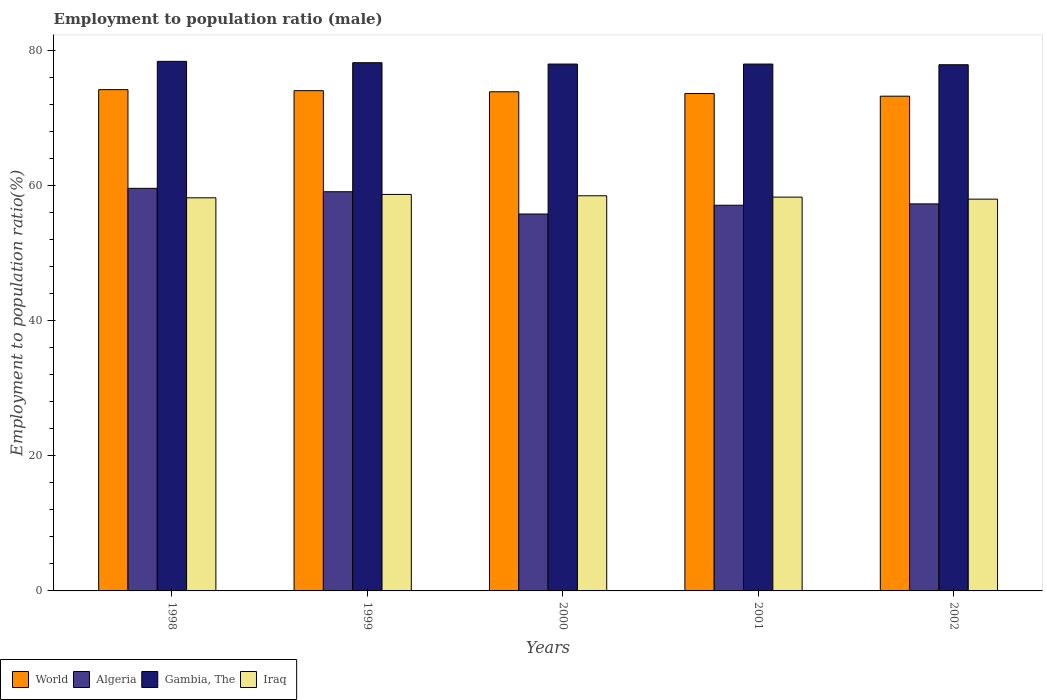How many different coloured bars are there?
Ensure brevity in your answer.  4. How many groups of bars are there?
Your answer should be compact. 5. Are the number of bars per tick equal to the number of legend labels?
Offer a terse response. Yes. Are the number of bars on each tick of the X-axis equal?
Your answer should be compact. Yes. How many bars are there on the 2nd tick from the right?
Make the answer very short. 4. What is the employment to population ratio in World in 2002?
Provide a succinct answer. 73.25. Across all years, what is the maximum employment to population ratio in World?
Provide a succinct answer. 74.21. Across all years, what is the minimum employment to population ratio in Gambia, The?
Offer a terse response. 77.9. In which year was the employment to population ratio in World maximum?
Make the answer very short. 1998. What is the total employment to population ratio in Gambia, The in the graph?
Your answer should be compact. 390.5. What is the difference between the employment to population ratio in Algeria in 1998 and that in 2002?
Your response must be concise. 2.3. What is the difference between the employment to population ratio in World in 2000 and the employment to population ratio in Gambia, The in 2001?
Keep it short and to the point. -4.11. What is the average employment to population ratio in Gambia, The per year?
Provide a succinct answer. 78.1. In the year 1998, what is the difference between the employment to population ratio in World and employment to population ratio in Algeria?
Make the answer very short. 14.61. In how many years, is the employment to population ratio in Gambia, The greater than 24 %?
Offer a terse response. 5. What is the ratio of the employment to population ratio in Algeria in 1999 to that in 2000?
Ensure brevity in your answer.  1.06. What is the difference between the highest and the second highest employment to population ratio in Iraq?
Offer a terse response. 0.2. What is the difference between the highest and the lowest employment to population ratio in Iraq?
Your response must be concise. 0.7. What does the 2nd bar from the left in 1999 represents?
Provide a short and direct response. Algeria. What does the 4th bar from the right in 2001 represents?
Your answer should be compact. World. Is it the case that in every year, the sum of the employment to population ratio in Gambia, The and employment to population ratio in Iraq is greater than the employment to population ratio in World?
Ensure brevity in your answer.  Yes. Are all the bars in the graph horizontal?
Offer a very short reply. No. What is the difference between two consecutive major ticks on the Y-axis?
Offer a very short reply. 20. Are the values on the major ticks of Y-axis written in scientific E-notation?
Your answer should be compact. No. Does the graph contain any zero values?
Your answer should be very brief. No. Does the graph contain grids?
Keep it short and to the point. No. Where does the legend appear in the graph?
Your answer should be compact. Bottom left. How many legend labels are there?
Your answer should be compact. 4. How are the legend labels stacked?
Provide a short and direct response. Horizontal. What is the title of the graph?
Keep it short and to the point. Employment to population ratio (male). Does "Moldova" appear as one of the legend labels in the graph?
Make the answer very short. No. What is the label or title of the X-axis?
Your response must be concise. Years. What is the label or title of the Y-axis?
Your answer should be compact. Employment to population ratio(%). What is the Employment to population ratio(%) of World in 1998?
Provide a short and direct response. 74.21. What is the Employment to population ratio(%) in Algeria in 1998?
Your answer should be compact. 59.6. What is the Employment to population ratio(%) of Gambia, The in 1998?
Provide a succinct answer. 78.4. What is the Employment to population ratio(%) in Iraq in 1998?
Your response must be concise. 58.2. What is the Employment to population ratio(%) of World in 1999?
Keep it short and to the point. 74.06. What is the Employment to population ratio(%) of Algeria in 1999?
Provide a succinct answer. 59.1. What is the Employment to population ratio(%) of Gambia, The in 1999?
Provide a succinct answer. 78.2. What is the Employment to population ratio(%) of Iraq in 1999?
Ensure brevity in your answer.  58.7. What is the Employment to population ratio(%) of World in 2000?
Your answer should be very brief. 73.89. What is the Employment to population ratio(%) in Algeria in 2000?
Offer a very short reply. 55.8. What is the Employment to population ratio(%) of Gambia, The in 2000?
Provide a short and direct response. 78. What is the Employment to population ratio(%) of Iraq in 2000?
Your response must be concise. 58.5. What is the Employment to population ratio(%) of World in 2001?
Keep it short and to the point. 73.64. What is the Employment to population ratio(%) of Algeria in 2001?
Offer a very short reply. 57.1. What is the Employment to population ratio(%) of Gambia, The in 2001?
Provide a succinct answer. 78. What is the Employment to population ratio(%) of Iraq in 2001?
Provide a succinct answer. 58.3. What is the Employment to population ratio(%) in World in 2002?
Your answer should be very brief. 73.25. What is the Employment to population ratio(%) of Algeria in 2002?
Your response must be concise. 57.3. What is the Employment to population ratio(%) in Gambia, The in 2002?
Offer a terse response. 77.9. What is the Employment to population ratio(%) in Iraq in 2002?
Give a very brief answer. 58. Across all years, what is the maximum Employment to population ratio(%) of World?
Your answer should be compact. 74.21. Across all years, what is the maximum Employment to population ratio(%) in Algeria?
Your answer should be very brief. 59.6. Across all years, what is the maximum Employment to population ratio(%) in Gambia, The?
Make the answer very short. 78.4. Across all years, what is the maximum Employment to population ratio(%) of Iraq?
Offer a very short reply. 58.7. Across all years, what is the minimum Employment to population ratio(%) in World?
Your answer should be compact. 73.25. Across all years, what is the minimum Employment to population ratio(%) in Algeria?
Make the answer very short. 55.8. Across all years, what is the minimum Employment to population ratio(%) in Gambia, The?
Ensure brevity in your answer.  77.9. What is the total Employment to population ratio(%) of World in the graph?
Give a very brief answer. 369.05. What is the total Employment to population ratio(%) of Algeria in the graph?
Ensure brevity in your answer.  288.9. What is the total Employment to population ratio(%) of Gambia, The in the graph?
Make the answer very short. 390.5. What is the total Employment to population ratio(%) of Iraq in the graph?
Give a very brief answer. 291.7. What is the difference between the Employment to population ratio(%) of World in 1998 and that in 1999?
Offer a very short reply. 0.15. What is the difference between the Employment to population ratio(%) in Gambia, The in 1998 and that in 1999?
Give a very brief answer. 0.2. What is the difference between the Employment to population ratio(%) of Iraq in 1998 and that in 1999?
Your answer should be very brief. -0.5. What is the difference between the Employment to population ratio(%) of World in 1998 and that in 2000?
Offer a very short reply. 0.32. What is the difference between the Employment to population ratio(%) of Algeria in 1998 and that in 2000?
Keep it short and to the point. 3.8. What is the difference between the Employment to population ratio(%) in Iraq in 1998 and that in 2000?
Give a very brief answer. -0.3. What is the difference between the Employment to population ratio(%) of World in 1998 and that in 2001?
Offer a terse response. 0.57. What is the difference between the Employment to population ratio(%) in Gambia, The in 1998 and that in 2001?
Your response must be concise. 0.4. What is the difference between the Employment to population ratio(%) of Iraq in 1998 and that in 2001?
Provide a short and direct response. -0.1. What is the difference between the Employment to population ratio(%) of World in 1998 and that in 2002?
Offer a terse response. 0.97. What is the difference between the Employment to population ratio(%) of Algeria in 1998 and that in 2002?
Offer a very short reply. 2.3. What is the difference between the Employment to population ratio(%) of Gambia, The in 1998 and that in 2002?
Your answer should be very brief. 0.5. What is the difference between the Employment to population ratio(%) of Algeria in 1999 and that in 2000?
Your response must be concise. 3.3. What is the difference between the Employment to population ratio(%) in World in 1999 and that in 2001?
Ensure brevity in your answer.  0.42. What is the difference between the Employment to population ratio(%) in Algeria in 1999 and that in 2001?
Give a very brief answer. 2. What is the difference between the Employment to population ratio(%) of Iraq in 1999 and that in 2001?
Your response must be concise. 0.4. What is the difference between the Employment to population ratio(%) in World in 1999 and that in 2002?
Your response must be concise. 0.81. What is the difference between the Employment to population ratio(%) of Algeria in 1999 and that in 2002?
Ensure brevity in your answer.  1.8. What is the difference between the Employment to population ratio(%) in Iraq in 1999 and that in 2002?
Give a very brief answer. 0.7. What is the difference between the Employment to population ratio(%) in World in 2000 and that in 2001?
Offer a terse response. 0.26. What is the difference between the Employment to population ratio(%) in Algeria in 2000 and that in 2001?
Provide a succinct answer. -1.3. What is the difference between the Employment to population ratio(%) in Gambia, The in 2000 and that in 2001?
Ensure brevity in your answer.  0. What is the difference between the Employment to population ratio(%) of World in 2000 and that in 2002?
Your answer should be compact. 0.65. What is the difference between the Employment to population ratio(%) of Iraq in 2000 and that in 2002?
Offer a terse response. 0.5. What is the difference between the Employment to population ratio(%) of World in 2001 and that in 2002?
Offer a terse response. 0.39. What is the difference between the Employment to population ratio(%) of Algeria in 2001 and that in 2002?
Make the answer very short. -0.2. What is the difference between the Employment to population ratio(%) of Gambia, The in 2001 and that in 2002?
Your response must be concise. 0.1. What is the difference between the Employment to population ratio(%) in World in 1998 and the Employment to population ratio(%) in Algeria in 1999?
Your answer should be compact. 15.11. What is the difference between the Employment to population ratio(%) in World in 1998 and the Employment to population ratio(%) in Gambia, The in 1999?
Ensure brevity in your answer.  -3.99. What is the difference between the Employment to population ratio(%) of World in 1998 and the Employment to population ratio(%) of Iraq in 1999?
Provide a succinct answer. 15.51. What is the difference between the Employment to population ratio(%) of Algeria in 1998 and the Employment to population ratio(%) of Gambia, The in 1999?
Your answer should be compact. -18.6. What is the difference between the Employment to population ratio(%) in World in 1998 and the Employment to population ratio(%) in Algeria in 2000?
Offer a very short reply. 18.41. What is the difference between the Employment to population ratio(%) of World in 1998 and the Employment to population ratio(%) of Gambia, The in 2000?
Give a very brief answer. -3.79. What is the difference between the Employment to population ratio(%) of World in 1998 and the Employment to population ratio(%) of Iraq in 2000?
Make the answer very short. 15.71. What is the difference between the Employment to population ratio(%) of Algeria in 1998 and the Employment to population ratio(%) of Gambia, The in 2000?
Offer a terse response. -18.4. What is the difference between the Employment to population ratio(%) of Algeria in 1998 and the Employment to population ratio(%) of Iraq in 2000?
Offer a very short reply. 1.1. What is the difference between the Employment to population ratio(%) of World in 1998 and the Employment to population ratio(%) of Algeria in 2001?
Your answer should be compact. 17.11. What is the difference between the Employment to population ratio(%) in World in 1998 and the Employment to population ratio(%) in Gambia, The in 2001?
Give a very brief answer. -3.79. What is the difference between the Employment to population ratio(%) in World in 1998 and the Employment to population ratio(%) in Iraq in 2001?
Your response must be concise. 15.91. What is the difference between the Employment to population ratio(%) in Algeria in 1998 and the Employment to population ratio(%) in Gambia, The in 2001?
Ensure brevity in your answer.  -18.4. What is the difference between the Employment to population ratio(%) in Gambia, The in 1998 and the Employment to population ratio(%) in Iraq in 2001?
Your response must be concise. 20.1. What is the difference between the Employment to population ratio(%) in World in 1998 and the Employment to population ratio(%) in Algeria in 2002?
Keep it short and to the point. 16.91. What is the difference between the Employment to population ratio(%) in World in 1998 and the Employment to population ratio(%) in Gambia, The in 2002?
Offer a very short reply. -3.69. What is the difference between the Employment to population ratio(%) in World in 1998 and the Employment to population ratio(%) in Iraq in 2002?
Ensure brevity in your answer.  16.21. What is the difference between the Employment to population ratio(%) of Algeria in 1998 and the Employment to population ratio(%) of Gambia, The in 2002?
Make the answer very short. -18.3. What is the difference between the Employment to population ratio(%) in Algeria in 1998 and the Employment to population ratio(%) in Iraq in 2002?
Make the answer very short. 1.6. What is the difference between the Employment to population ratio(%) in Gambia, The in 1998 and the Employment to population ratio(%) in Iraq in 2002?
Make the answer very short. 20.4. What is the difference between the Employment to population ratio(%) of World in 1999 and the Employment to population ratio(%) of Algeria in 2000?
Provide a short and direct response. 18.26. What is the difference between the Employment to population ratio(%) of World in 1999 and the Employment to population ratio(%) of Gambia, The in 2000?
Offer a terse response. -3.94. What is the difference between the Employment to population ratio(%) in World in 1999 and the Employment to population ratio(%) in Iraq in 2000?
Your answer should be very brief. 15.56. What is the difference between the Employment to population ratio(%) of Algeria in 1999 and the Employment to population ratio(%) of Gambia, The in 2000?
Provide a succinct answer. -18.9. What is the difference between the Employment to population ratio(%) in World in 1999 and the Employment to population ratio(%) in Algeria in 2001?
Provide a short and direct response. 16.96. What is the difference between the Employment to population ratio(%) in World in 1999 and the Employment to population ratio(%) in Gambia, The in 2001?
Offer a very short reply. -3.94. What is the difference between the Employment to population ratio(%) of World in 1999 and the Employment to population ratio(%) of Iraq in 2001?
Provide a short and direct response. 15.76. What is the difference between the Employment to population ratio(%) of Algeria in 1999 and the Employment to population ratio(%) of Gambia, The in 2001?
Your answer should be very brief. -18.9. What is the difference between the Employment to population ratio(%) in Algeria in 1999 and the Employment to population ratio(%) in Iraq in 2001?
Keep it short and to the point. 0.8. What is the difference between the Employment to population ratio(%) of World in 1999 and the Employment to population ratio(%) of Algeria in 2002?
Give a very brief answer. 16.76. What is the difference between the Employment to population ratio(%) in World in 1999 and the Employment to population ratio(%) in Gambia, The in 2002?
Make the answer very short. -3.84. What is the difference between the Employment to population ratio(%) of World in 1999 and the Employment to population ratio(%) of Iraq in 2002?
Your answer should be very brief. 16.06. What is the difference between the Employment to population ratio(%) in Algeria in 1999 and the Employment to population ratio(%) in Gambia, The in 2002?
Provide a short and direct response. -18.8. What is the difference between the Employment to population ratio(%) of Algeria in 1999 and the Employment to population ratio(%) of Iraq in 2002?
Ensure brevity in your answer.  1.1. What is the difference between the Employment to population ratio(%) in Gambia, The in 1999 and the Employment to population ratio(%) in Iraq in 2002?
Provide a succinct answer. 20.2. What is the difference between the Employment to population ratio(%) in World in 2000 and the Employment to population ratio(%) in Algeria in 2001?
Make the answer very short. 16.79. What is the difference between the Employment to population ratio(%) in World in 2000 and the Employment to population ratio(%) in Gambia, The in 2001?
Give a very brief answer. -4.11. What is the difference between the Employment to population ratio(%) of World in 2000 and the Employment to population ratio(%) of Iraq in 2001?
Provide a short and direct response. 15.59. What is the difference between the Employment to population ratio(%) in Algeria in 2000 and the Employment to population ratio(%) in Gambia, The in 2001?
Provide a short and direct response. -22.2. What is the difference between the Employment to population ratio(%) of Gambia, The in 2000 and the Employment to population ratio(%) of Iraq in 2001?
Ensure brevity in your answer.  19.7. What is the difference between the Employment to population ratio(%) in World in 2000 and the Employment to population ratio(%) in Algeria in 2002?
Your response must be concise. 16.59. What is the difference between the Employment to population ratio(%) of World in 2000 and the Employment to population ratio(%) of Gambia, The in 2002?
Ensure brevity in your answer.  -4.01. What is the difference between the Employment to population ratio(%) of World in 2000 and the Employment to population ratio(%) of Iraq in 2002?
Your answer should be very brief. 15.89. What is the difference between the Employment to population ratio(%) of Algeria in 2000 and the Employment to population ratio(%) of Gambia, The in 2002?
Your answer should be very brief. -22.1. What is the difference between the Employment to population ratio(%) in World in 2001 and the Employment to population ratio(%) in Algeria in 2002?
Your response must be concise. 16.34. What is the difference between the Employment to population ratio(%) of World in 2001 and the Employment to population ratio(%) of Gambia, The in 2002?
Ensure brevity in your answer.  -4.26. What is the difference between the Employment to population ratio(%) in World in 2001 and the Employment to population ratio(%) in Iraq in 2002?
Provide a short and direct response. 15.64. What is the difference between the Employment to population ratio(%) in Algeria in 2001 and the Employment to population ratio(%) in Gambia, The in 2002?
Provide a short and direct response. -20.8. What is the difference between the Employment to population ratio(%) in Gambia, The in 2001 and the Employment to population ratio(%) in Iraq in 2002?
Ensure brevity in your answer.  20. What is the average Employment to population ratio(%) in World per year?
Ensure brevity in your answer.  73.81. What is the average Employment to population ratio(%) in Algeria per year?
Offer a very short reply. 57.78. What is the average Employment to population ratio(%) of Gambia, The per year?
Your answer should be compact. 78.1. What is the average Employment to population ratio(%) of Iraq per year?
Give a very brief answer. 58.34. In the year 1998, what is the difference between the Employment to population ratio(%) in World and Employment to population ratio(%) in Algeria?
Offer a very short reply. 14.61. In the year 1998, what is the difference between the Employment to population ratio(%) in World and Employment to population ratio(%) in Gambia, The?
Keep it short and to the point. -4.19. In the year 1998, what is the difference between the Employment to population ratio(%) of World and Employment to population ratio(%) of Iraq?
Give a very brief answer. 16.01. In the year 1998, what is the difference between the Employment to population ratio(%) of Algeria and Employment to population ratio(%) of Gambia, The?
Keep it short and to the point. -18.8. In the year 1998, what is the difference between the Employment to population ratio(%) in Algeria and Employment to population ratio(%) in Iraq?
Provide a succinct answer. 1.4. In the year 1998, what is the difference between the Employment to population ratio(%) of Gambia, The and Employment to population ratio(%) of Iraq?
Keep it short and to the point. 20.2. In the year 1999, what is the difference between the Employment to population ratio(%) of World and Employment to population ratio(%) of Algeria?
Give a very brief answer. 14.96. In the year 1999, what is the difference between the Employment to population ratio(%) of World and Employment to population ratio(%) of Gambia, The?
Make the answer very short. -4.14. In the year 1999, what is the difference between the Employment to population ratio(%) of World and Employment to population ratio(%) of Iraq?
Ensure brevity in your answer.  15.36. In the year 1999, what is the difference between the Employment to population ratio(%) in Algeria and Employment to population ratio(%) in Gambia, The?
Offer a terse response. -19.1. In the year 2000, what is the difference between the Employment to population ratio(%) of World and Employment to population ratio(%) of Algeria?
Your answer should be very brief. 18.09. In the year 2000, what is the difference between the Employment to population ratio(%) of World and Employment to population ratio(%) of Gambia, The?
Ensure brevity in your answer.  -4.11. In the year 2000, what is the difference between the Employment to population ratio(%) in World and Employment to population ratio(%) in Iraq?
Offer a terse response. 15.39. In the year 2000, what is the difference between the Employment to population ratio(%) in Algeria and Employment to population ratio(%) in Gambia, The?
Offer a terse response. -22.2. In the year 2000, what is the difference between the Employment to population ratio(%) in Gambia, The and Employment to population ratio(%) in Iraq?
Ensure brevity in your answer.  19.5. In the year 2001, what is the difference between the Employment to population ratio(%) in World and Employment to population ratio(%) in Algeria?
Your answer should be compact. 16.54. In the year 2001, what is the difference between the Employment to population ratio(%) of World and Employment to population ratio(%) of Gambia, The?
Your answer should be compact. -4.36. In the year 2001, what is the difference between the Employment to population ratio(%) of World and Employment to population ratio(%) of Iraq?
Your answer should be compact. 15.34. In the year 2001, what is the difference between the Employment to population ratio(%) of Algeria and Employment to population ratio(%) of Gambia, The?
Make the answer very short. -20.9. In the year 2002, what is the difference between the Employment to population ratio(%) of World and Employment to population ratio(%) of Algeria?
Keep it short and to the point. 15.95. In the year 2002, what is the difference between the Employment to population ratio(%) of World and Employment to population ratio(%) of Gambia, The?
Make the answer very short. -4.65. In the year 2002, what is the difference between the Employment to population ratio(%) of World and Employment to population ratio(%) of Iraq?
Offer a very short reply. 15.25. In the year 2002, what is the difference between the Employment to population ratio(%) in Algeria and Employment to population ratio(%) in Gambia, The?
Offer a very short reply. -20.6. What is the ratio of the Employment to population ratio(%) in Algeria in 1998 to that in 1999?
Your answer should be compact. 1.01. What is the ratio of the Employment to population ratio(%) of Gambia, The in 1998 to that in 1999?
Provide a succinct answer. 1. What is the ratio of the Employment to population ratio(%) of World in 1998 to that in 2000?
Make the answer very short. 1. What is the ratio of the Employment to population ratio(%) in Algeria in 1998 to that in 2000?
Offer a very short reply. 1.07. What is the ratio of the Employment to population ratio(%) in Iraq in 1998 to that in 2000?
Make the answer very short. 0.99. What is the ratio of the Employment to population ratio(%) in Algeria in 1998 to that in 2001?
Your answer should be very brief. 1.04. What is the ratio of the Employment to population ratio(%) of Gambia, The in 1998 to that in 2001?
Offer a very short reply. 1.01. What is the ratio of the Employment to population ratio(%) of World in 1998 to that in 2002?
Provide a succinct answer. 1.01. What is the ratio of the Employment to population ratio(%) of Algeria in 1998 to that in 2002?
Provide a short and direct response. 1.04. What is the ratio of the Employment to population ratio(%) in Gambia, The in 1998 to that in 2002?
Your answer should be very brief. 1.01. What is the ratio of the Employment to population ratio(%) of World in 1999 to that in 2000?
Ensure brevity in your answer.  1. What is the ratio of the Employment to population ratio(%) of Algeria in 1999 to that in 2000?
Your answer should be compact. 1.06. What is the ratio of the Employment to population ratio(%) in World in 1999 to that in 2001?
Give a very brief answer. 1.01. What is the ratio of the Employment to population ratio(%) of Algeria in 1999 to that in 2001?
Provide a succinct answer. 1.03. What is the ratio of the Employment to population ratio(%) of Gambia, The in 1999 to that in 2001?
Offer a very short reply. 1. What is the ratio of the Employment to population ratio(%) in World in 1999 to that in 2002?
Your answer should be very brief. 1.01. What is the ratio of the Employment to population ratio(%) in Algeria in 1999 to that in 2002?
Your response must be concise. 1.03. What is the ratio of the Employment to population ratio(%) in Gambia, The in 1999 to that in 2002?
Provide a succinct answer. 1. What is the ratio of the Employment to population ratio(%) of Iraq in 1999 to that in 2002?
Offer a very short reply. 1.01. What is the ratio of the Employment to population ratio(%) in World in 2000 to that in 2001?
Offer a terse response. 1. What is the ratio of the Employment to population ratio(%) in Algeria in 2000 to that in 2001?
Provide a succinct answer. 0.98. What is the ratio of the Employment to population ratio(%) of Gambia, The in 2000 to that in 2001?
Offer a terse response. 1. What is the ratio of the Employment to population ratio(%) of World in 2000 to that in 2002?
Ensure brevity in your answer.  1.01. What is the ratio of the Employment to population ratio(%) of Algeria in 2000 to that in 2002?
Offer a terse response. 0.97. What is the ratio of the Employment to population ratio(%) of Gambia, The in 2000 to that in 2002?
Your response must be concise. 1. What is the ratio of the Employment to population ratio(%) of Iraq in 2000 to that in 2002?
Provide a short and direct response. 1.01. What is the ratio of the Employment to population ratio(%) in World in 2001 to that in 2002?
Your answer should be very brief. 1.01. What is the ratio of the Employment to population ratio(%) of Algeria in 2001 to that in 2002?
Ensure brevity in your answer.  1. What is the difference between the highest and the second highest Employment to population ratio(%) of World?
Your answer should be compact. 0.15. What is the difference between the highest and the second highest Employment to population ratio(%) in Algeria?
Offer a terse response. 0.5. What is the difference between the highest and the second highest Employment to population ratio(%) of Gambia, The?
Keep it short and to the point. 0.2. What is the difference between the highest and the lowest Employment to population ratio(%) in World?
Give a very brief answer. 0.97. What is the difference between the highest and the lowest Employment to population ratio(%) in Algeria?
Give a very brief answer. 3.8. What is the difference between the highest and the lowest Employment to population ratio(%) of Gambia, The?
Make the answer very short. 0.5. 